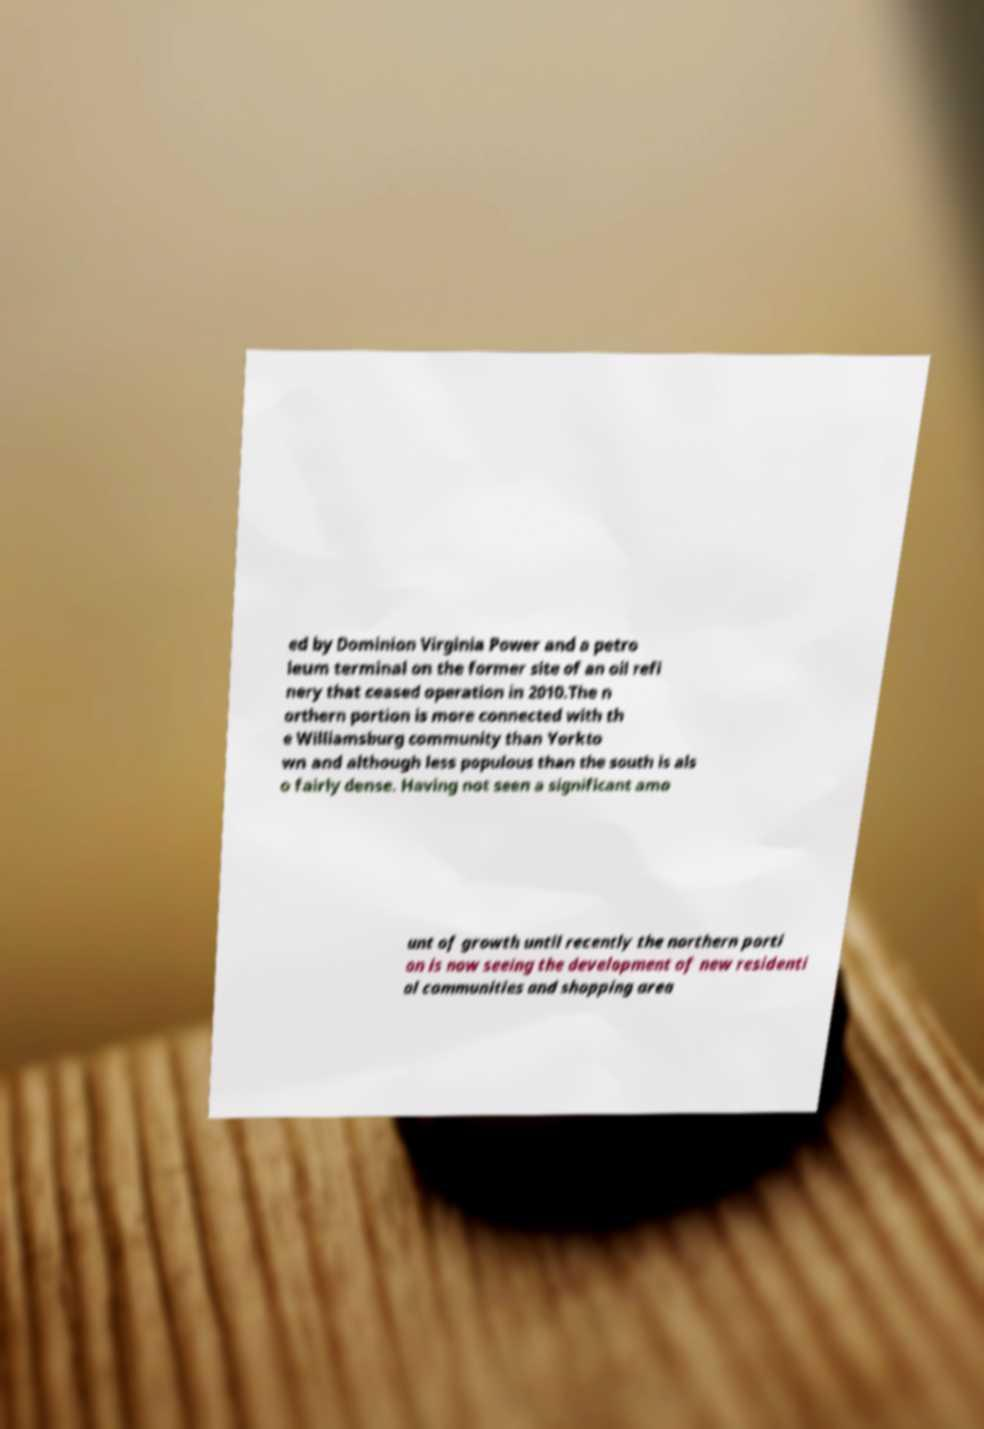There's text embedded in this image that I need extracted. Can you transcribe it verbatim? ed by Dominion Virginia Power and a petro leum terminal on the former site of an oil refi nery that ceased operation in 2010.The n orthern portion is more connected with th e Williamsburg community than Yorkto wn and although less populous than the south is als o fairly dense. Having not seen a significant amo unt of growth until recently the northern porti on is now seeing the development of new residenti al communities and shopping area 